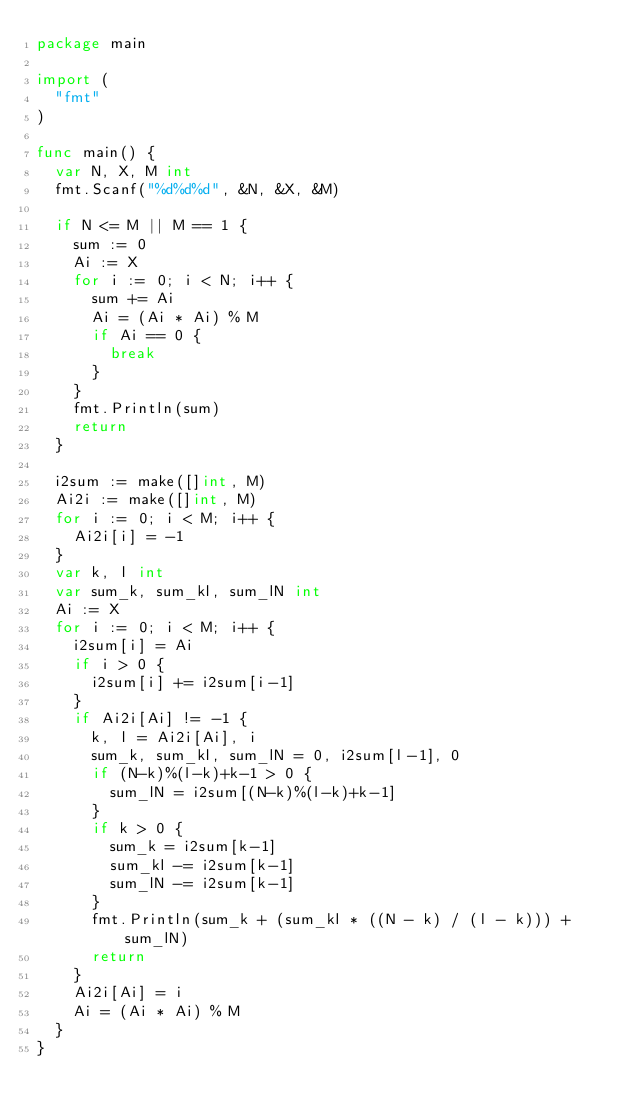Convert code to text. <code><loc_0><loc_0><loc_500><loc_500><_Go_>package main

import (
	"fmt"
)

func main() {
	var N, X, M int
	fmt.Scanf("%d%d%d", &N, &X, &M)

	if N <= M || M == 1 {
		sum := 0
		Ai := X
		for i := 0; i < N; i++ {
			sum += Ai
			Ai = (Ai * Ai) % M
			if Ai == 0 {
				break
			}
		}
		fmt.Println(sum)
		return
	}

	i2sum := make([]int, M)
	Ai2i := make([]int, M)
	for i := 0; i < M; i++ {
		Ai2i[i] = -1
	}
	var k, l int
	var sum_k, sum_kl, sum_lN int
	Ai := X
	for i := 0; i < M; i++ {
		i2sum[i] = Ai
		if i > 0 {
			i2sum[i] += i2sum[i-1]
		}
		if Ai2i[Ai] != -1 {
			k, l = Ai2i[Ai], i
			sum_k, sum_kl, sum_lN = 0, i2sum[l-1], 0
			if (N-k)%(l-k)+k-1 > 0 {
				sum_lN = i2sum[(N-k)%(l-k)+k-1]
			}
			if k > 0 {
				sum_k = i2sum[k-1]
				sum_kl -= i2sum[k-1]
				sum_lN -= i2sum[k-1]
			}
			fmt.Println(sum_k + (sum_kl * ((N - k) / (l - k))) + sum_lN)
			return
		}
		Ai2i[Ai] = i
		Ai = (Ai * Ai) % M
	}
}
</code> 